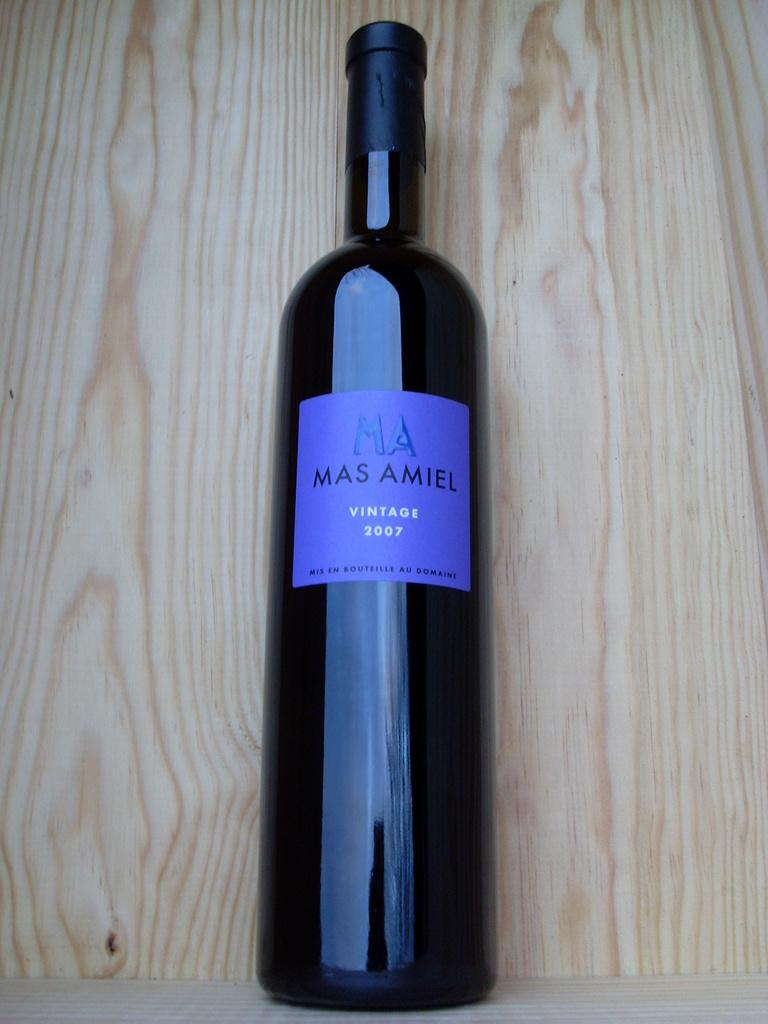<image>
Write a terse but informative summary of the picture. A 2007 brand of wine from a bottle called Mas Amiel 